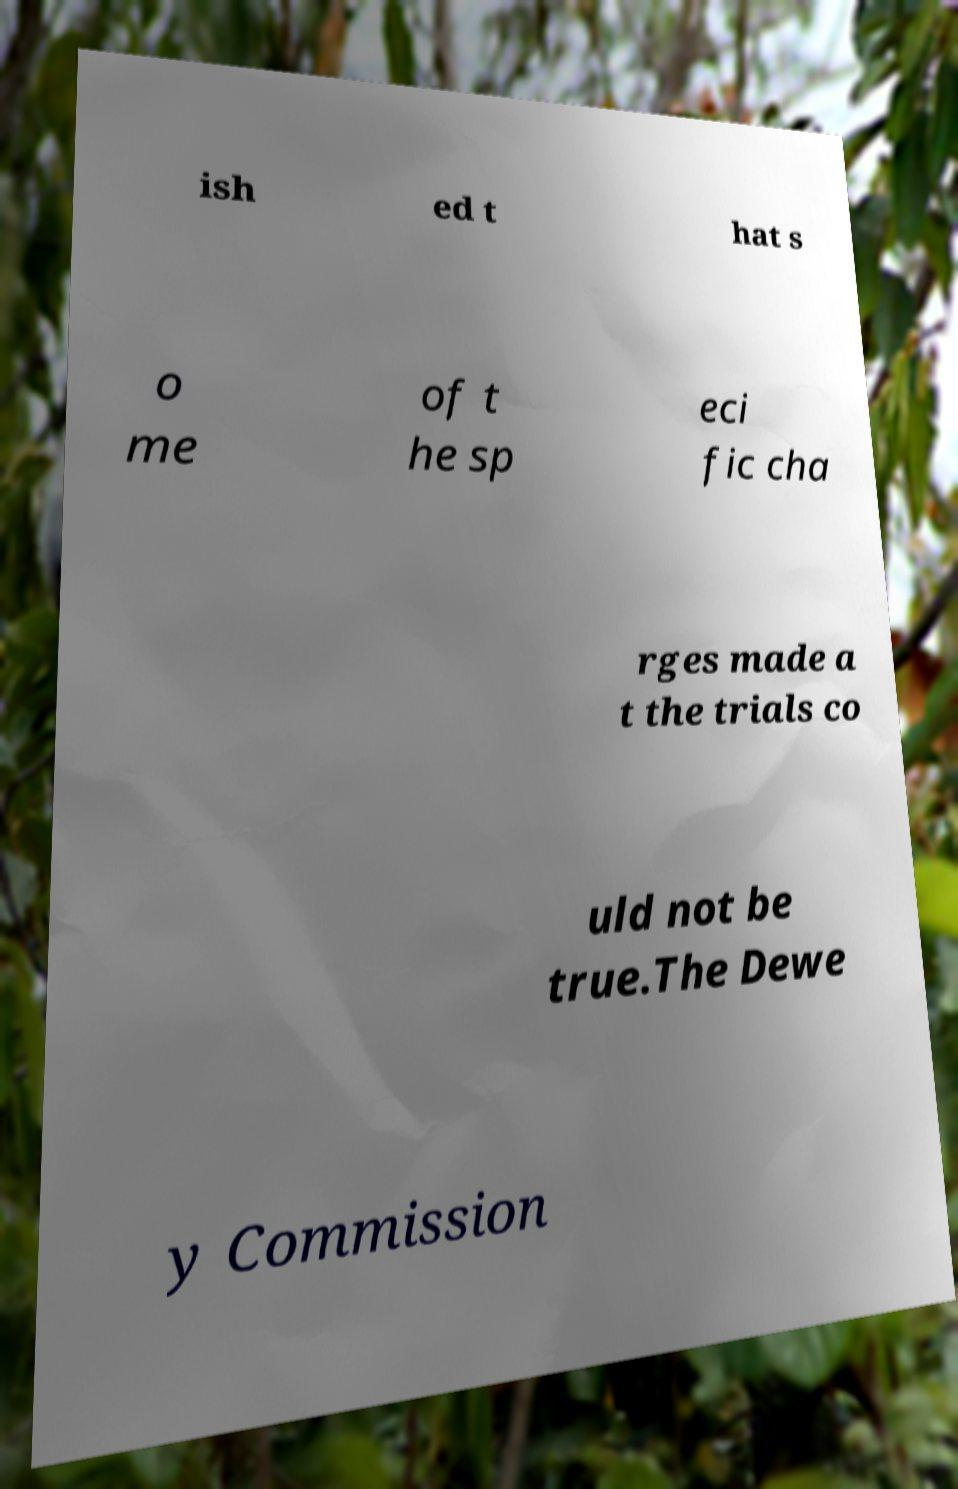Can you accurately transcribe the text from the provided image for me? ish ed t hat s o me of t he sp eci fic cha rges made a t the trials co uld not be true.The Dewe y Commission 